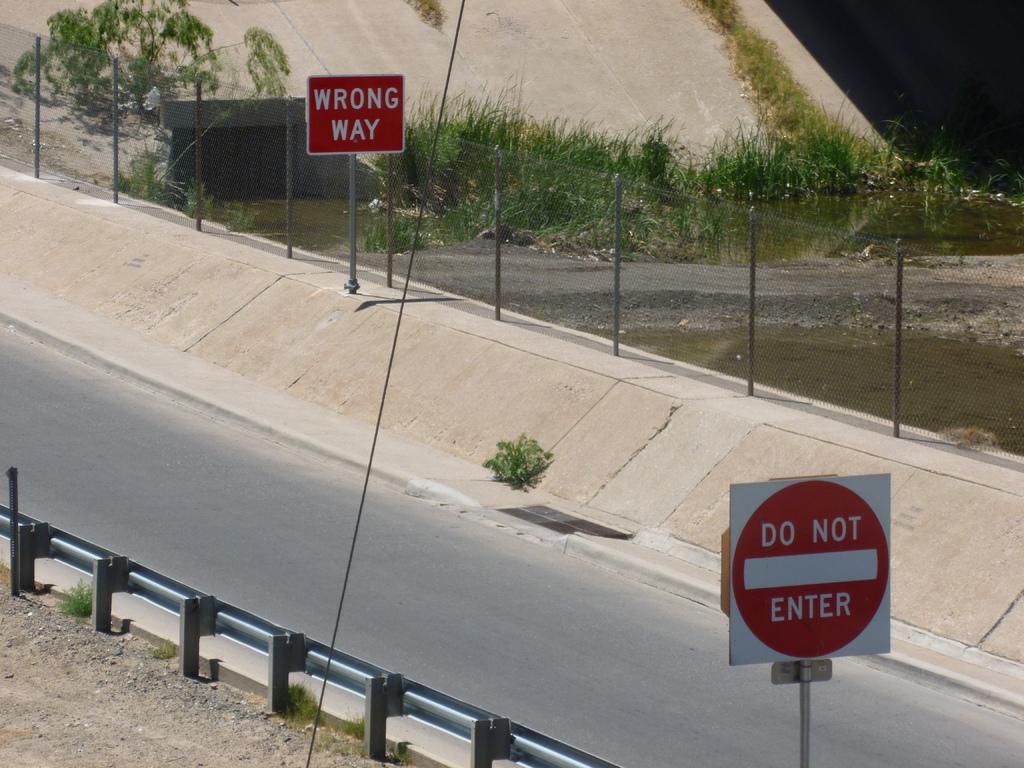What are the road signs trying to let drivers know?
Your answer should be compact. Wrong way. Is there a do not enter sign?
Offer a terse response. Yes. 